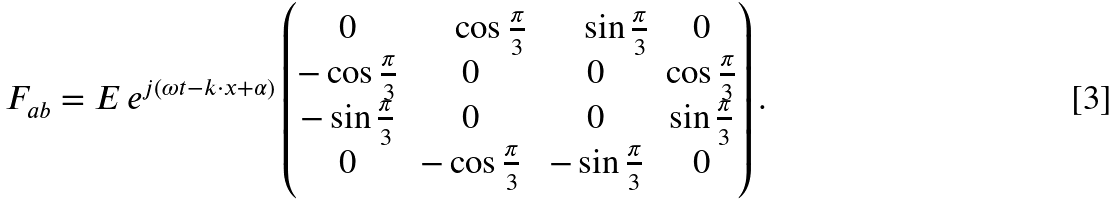Convert formula to latex. <formula><loc_0><loc_0><loc_500><loc_500>F _ { a b } = E \, e ^ { j ( \omega t - k \cdot x + \alpha ) } \begin{pmatrix} 0 & \quad \, \cos \frac { \pi } { 3 } & \quad \, \sin \frac { \pi } { 3 } & 0 \\ - \cos \frac { \pi } { 3 } & 0 & 0 & \cos \frac { \pi } { 3 } \\ - \sin \frac { \pi } { 3 } & 0 & 0 & \sin \frac { \pi } { 3 } \\ 0 & - \cos \frac { \pi } { 3 } & - \sin \frac { \pi } { 3 } & 0 \\ \end{pmatrix} .</formula> 